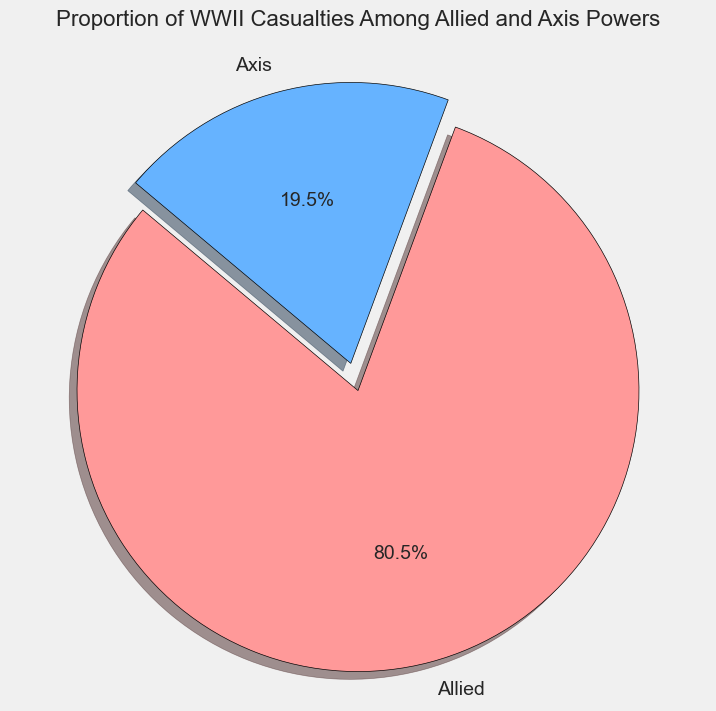What is the total proportion of casualties for the Allied and Axis Powers? The figure shows a pie chart with proportions represented for Allied and Axis powers. According to the chart, the Allied Powers have a larger slice compared to the Axis Powers. On the pie chart, the percentage for the Allied Powers is shown as 78.3%, and for the Axis Powers, it is 21.7%. Adding these two values gives 100% in total.
Answer: 100% Which side had the greater proportion of casualties, Allied or Axis Powers? By observing the pie chart, we see that the Allied Powers have a clearly larger slice than the Axis Powers. The percentage value shown for the Allied Powers is 78.3%, while for the Axis Powers, it is 21.7%. Therefore, the Allied Powers had a greater proportion of casualties.
Answer: Allied Powers What is the difference in the proportion of casualties between Allied and Axis Powers? The pie chart shows that the Allied Powers have 78.3% of casualties, while the Axis Powers have 21.7%. To find the difference, subtract the smaller value from the larger one: 78.3% - 21.7% = 56.6%.
Answer: 56.6% Which side is represented by the color red in the pie chart? By observing the pie chart, we can see the legend associating the color red with one of the slices. The slice colored red corresponds to the Allied Powers.
Answer: Allied Powers What part of the pie chart is exploded or offset from the circle? Observing the pie chart, the slice that is separated and appears to stand out is the one representing the Allied Powers.
Answer: Allied Powers What percentage of casualties did the Axis Powers account for, according to the chart? The pie chart denotes the percentage values for each segment representing the Allied and Axis Powers. The Axis Powers' segment is indicated to account for 21.7% of the total casualties.
Answer: 21.7% What is the combined proportion of casualties for the Soviet Union and Germany? To obtain this information, consult the pie chart where specific countries are not individually labeled, but noteworthy major contributors like the Soviet Union and Germany fall under the categories of Allied and Axis, respectively. Since individual countries are not indicated, we cannot directly infer the combined proportion from the pie chart alone. To solve manually, data states Soviet Union: 26700000 and Germany: 7500000. First sum the values: 26700000 + 7500000 = 34200000. Total casualties are: 51346000 + 14202000 = 65548000. Then, compute the percentage: (34200000 / 65548000) * 100 ≈ 52.2%.
Answer: 52.2% How much greater in percentage points is the Allied Powers' casualties proportion compared to the Axis Powers'? From the pie chart, the percentages are 78.3% for Allied Powers and 21.7% for Axis Powers. Subtracting these values: 78.3% - 21.7% = 56.6%. The Allied Powers' casualties are 56.6 percentage points greater.
Answer: 56.6% Does the pie chart depict the casualties proportion balanced between Allied and Axis Powers? The pie chart shows two slices representing the Allied and Axis Powers with their respective percentages. The Allied Powers' slice takes up a substantially larger portion (78.3%) compared to the Axis Powers' slice (21.7%), indicating a significant imbalance.
Answer: No Based on the visual representation, what is the overall proportion of casualties on the Allied side compared to the total? The pie chart shows the Allied side accounting for 78.3% of the overall casualties among the represented groups.
Answer: 78.3% 